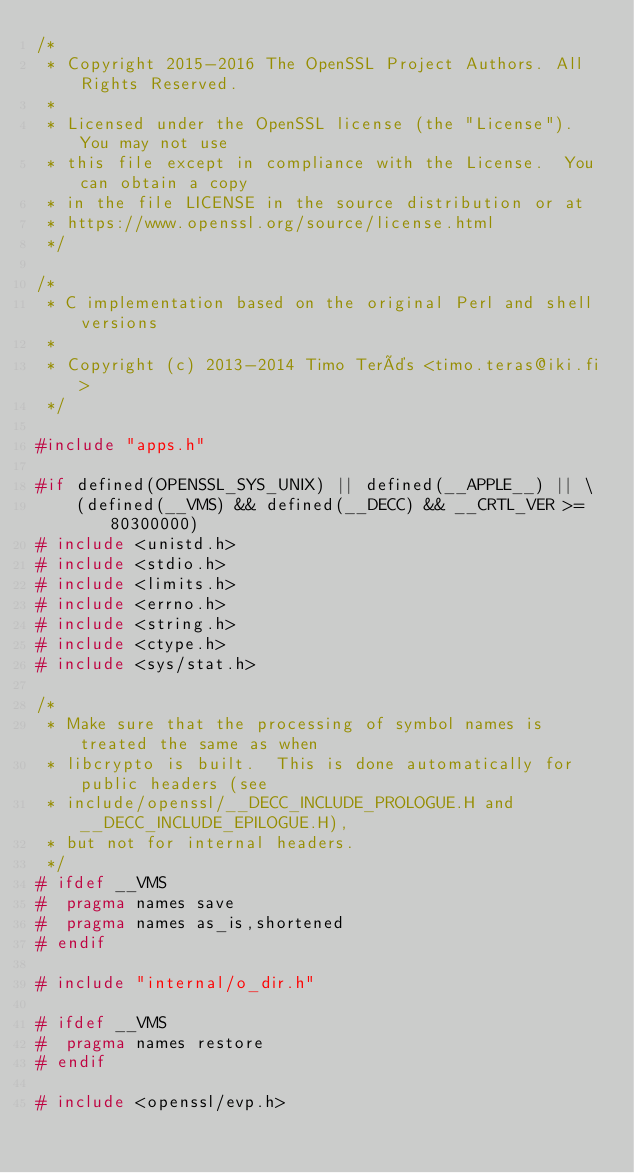Convert code to text. <code><loc_0><loc_0><loc_500><loc_500><_C_>/*
 * Copyright 2015-2016 The OpenSSL Project Authors. All Rights Reserved.
 *
 * Licensed under the OpenSSL license (the "License").  You may not use
 * this file except in compliance with the License.  You can obtain a copy
 * in the file LICENSE in the source distribution or at
 * https://www.openssl.org/source/license.html
 */

/*
 * C implementation based on the original Perl and shell versions
 *
 * Copyright (c) 2013-2014 Timo Teräs <timo.teras@iki.fi>
 */

#include "apps.h"

#if defined(OPENSSL_SYS_UNIX) || defined(__APPLE__) || \
    (defined(__VMS) && defined(__DECC) && __CRTL_VER >= 80300000)
# include <unistd.h>
# include <stdio.h>
# include <limits.h>
# include <errno.h>
# include <string.h>
# include <ctype.h>
# include <sys/stat.h>

/*
 * Make sure that the processing of symbol names is treated the same as when
 * libcrypto is built.  This is done automatically for public headers (see
 * include/openssl/__DECC_INCLUDE_PROLOGUE.H and __DECC_INCLUDE_EPILOGUE.H),
 * but not for internal headers.
 */
# ifdef __VMS
#  pragma names save
#  pragma names as_is,shortened
# endif

# include "internal/o_dir.h"

# ifdef __VMS
#  pragma names restore
# endif

# include <openssl/evp.h></code> 